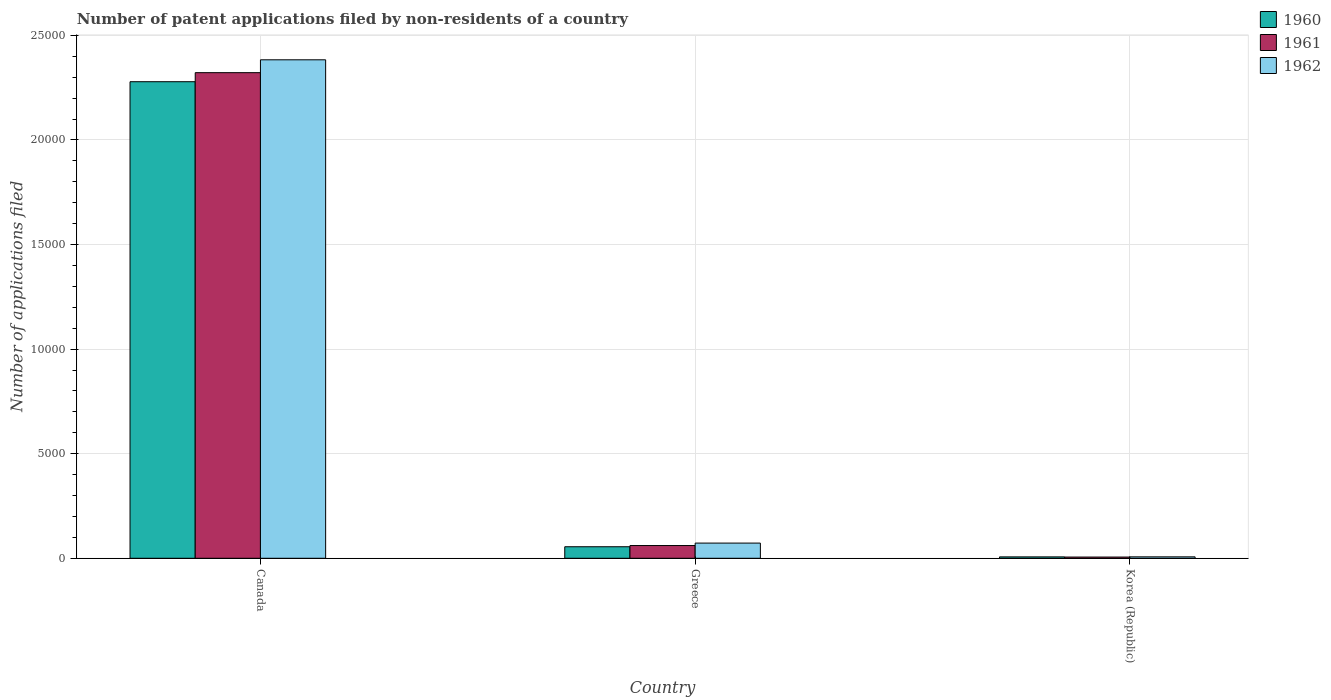How many different coloured bars are there?
Make the answer very short. 3. How many groups of bars are there?
Ensure brevity in your answer.  3. Are the number of bars per tick equal to the number of legend labels?
Provide a succinct answer. Yes. Are the number of bars on each tick of the X-axis equal?
Give a very brief answer. Yes. What is the number of applications filed in 1962 in Greece?
Offer a very short reply. 726. Across all countries, what is the maximum number of applications filed in 1961?
Offer a terse response. 2.32e+04. What is the total number of applications filed in 1962 in the graph?
Your response must be concise. 2.46e+04. What is the difference between the number of applications filed in 1960 in Canada and that in Greece?
Offer a terse response. 2.22e+04. What is the difference between the number of applications filed in 1962 in Greece and the number of applications filed in 1960 in Canada?
Your answer should be compact. -2.21e+04. What is the average number of applications filed in 1962 per country?
Provide a short and direct response. 8209.33. What is the difference between the number of applications filed of/in 1960 and number of applications filed of/in 1961 in Korea (Republic)?
Your answer should be very brief. 8. In how many countries, is the number of applications filed in 1962 greater than 17000?
Make the answer very short. 1. What is the ratio of the number of applications filed in 1960 in Canada to that in Greece?
Your response must be concise. 41.35. Is the number of applications filed in 1960 in Canada less than that in Korea (Republic)?
Provide a short and direct response. No. Is the difference between the number of applications filed in 1960 in Canada and Korea (Republic) greater than the difference between the number of applications filed in 1961 in Canada and Korea (Republic)?
Offer a terse response. No. What is the difference between the highest and the second highest number of applications filed in 1960?
Ensure brevity in your answer.  2.27e+04. What is the difference between the highest and the lowest number of applications filed in 1960?
Keep it short and to the point. 2.27e+04. Is the sum of the number of applications filed in 1961 in Canada and Greece greater than the maximum number of applications filed in 1962 across all countries?
Your answer should be compact. No. What does the 2nd bar from the right in Canada represents?
Your answer should be compact. 1961. Is it the case that in every country, the sum of the number of applications filed in 1962 and number of applications filed in 1960 is greater than the number of applications filed in 1961?
Your response must be concise. Yes. How many bars are there?
Offer a very short reply. 9. Are all the bars in the graph horizontal?
Offer a terse response. No. How many countries are there in the graph?
Your answer should be very brief. 3. How are the legend labels stacked?
Your answer should be very brief. Vertical. What is the title of the graph?
Offer a very short reply. Number of patent applications filed by non-residents of a country. What is the label or title of the X-axis?
Provide a succinct answer. Country. What is the label or title of the Y-axis?
Your response must be concise. Number of applications filed. What is the Number of applications filed in 1960 in Canada?
Your answer should be very brief. 2.28e+04. What is the Number of applications filed of 1961 in Canada?
Make the answer very short. 2.32e+04. What is the Number of applications filed in 1962 in Canada?
Provide a succinct answer. 2.38e+04. What is the Number of applications filed of 1960 in Greece?
Your answer should be compact. 551. What is the Number of applications filed of 1961 in Greece?
Ensure brevity in your answer.  609. What is the Number of applications filed of 1962 in Greece?
Your response must be concise. 726. What is the Number of applications filed of 1961 in Korea (Republic)?
Ensure brevity in your answer.  58. Across all countries, what is the maximum Number of applications filed of 1960?
Offer a terse response. 2.28e+04. Across all countries, what is the maximum Number of applications filed of 1961?
Offer a terse response. 2.32e+04. Across all countries, what is the maximum Number of applications filed of 1962?
Keep it short and to the point. 2.38e+04. Across all countries, what is the minimum Number of applications filed of 1960?
Ensure brevity in your answer.  66. Across all countries, what is the minimum Number of applications filed of 1962?
Provide a short and direct response. 68. What is the total Number of applications filed of 1960 in the graph?
Provide a succinct answer. 2.34e+04. What is the total Number of applications filed in 1961 in the graph?
Your response must be concise. 2.39e+04. What is the total Number of applications filed in 1962 in the graph?
Give a very brief answer. 2.46e+04. What is the difference between the Number of applications filed of 1960 in Canada and that in Greece?
Give a very brief answer. 2.22e+04. What is the difference between the Number of applications filed in 1961 in Canada and that in Greece?
Provide a succinct answer. 2.26e+04. What is the difference between the Number of applications filed of 1962 in Canada and that in Greece?
Keep it short and to the point. 2.31e+04. What is the difference between the Number of applications filed of 1960 in Canada and that in Korea (Republic)?
Offer a terse response. 2.27e+04. What is the difference between the Number of applications filed of 1961 in Canada and that in Korea (Republic)?
Keep it short and to the point. 2.32e+04. What is the difference between the Number of applications filed in 1962 in Canada and that in Korea (Republic)?
Offer a very short reply. 2.38e+04. What is the difference between the Number of applications filed in 1960 in Greece and that in Korea (Republic)?
Offer a terse response. 485. What is the difference between the Number of applications filed in 1961 in Greece and that in Korea (Republic)?
Your response must be concise. 551. What is the difference between the Number of applications filed in 1962 in Greece and that in Korea (Republic)?
Provide a short and direct response. 658. What is the difference between the Number of applications filed of 1960 in Canada and the Number of applications filed of 1961 in Greece?
Your response must be concise. 2.22e+04. What is the difference between the Number of applications filed in 1960 in Canada and the Number of applications filed in 1962 in Greece?
Keep it short and to the point. 2.21e+04. What is the difference between the Number of applications filed in 1961 in Canada and the Number of applications filed in 1962 in Greece?
Make the answer very short. 2.25e+04. What is the difference between the Number of applications filed of 1960 in Canada and the Number of applications filed of 1961 in Korea (Republic)?
Your answer should be compact. 2.27e+04. What is the difference between the Number of applications filed of 1960 in Canada and the Number of applications filed of 1962 in Korea (Republic)?
Ensure brevity in your answer.  2.27e+04. What is the difference between the Number of applications filed in 1961 in Canada and the Number of applications filed in 1962 in Korea (Republic)?
Provide a short and direct response. 2.32e+04. What is the difference between the Number of applications filed of 1960 in Greece and the Number of applications filed of 1961 in Korea (Republic)?
Offer a very short reply. 493. What is the difference between the Number of applications filed in 1960 in Greece and the Number of applications filed in 1962 in Korea (Republic)?
Ensure brevity in your answer.  483. What is the difference between the Number of applications filed in 1961 in Greece and the Number of applications filed in 1962 in Korea (Republic)?
Offer a terse response. 541. What is the average Number of applications filed of 1960 per country?
Provide a succinct answer. 7801. What is the average Number of applications filed of 1961 per country?
Your answer should be very brief. 7962. What is the average Number of applications filed in 1962 per country?
Keep it short and to the point. 8209.33. What is the difference between the Number of applications filed of 1960 and Number of applications filed of 1961 in Canada?
Your answer should be compact. -433. What is the difference between the Number of applications filed in 1960 and Number of applications filed in 1962 in Canada?
Give a very brief answer. -1048. What is the difference between the Number of applications filed of 1961 and Number of applications filed of 1962 in Canada?
Provide a short and direct response. -615. What is the difference between the Number of applications filed of 1960 and Number of applications filed of 1961 in Greece?
Keep it short and to the point. -58. What is the difference between the Number of applications filed in 1960 and Number of applications filed in 1962 in Greece?
Your answer should be very brief. -175. What is the difference between the Number of applications filed in 1961 and Number of applications filed in 1962 in Greece?
Give a very brief answer. -117. What is the difference between the Number of applications filed of 1960 and Number of applications filed of 1961 in Korea (Republic)?
Your answer should be very brief. 8. What is the difference between the Number of applications filed of 1960 and Number of applications filed of 1962 in Korea (Republic)?
Provide a short and direct response. -2. What is the difference between the Number of applications filed in 1961 and Number of applications filed in 1962 in Korea (Republic)?
Your answer should be compact. -10. What is the ratio of the Number of applications filed in 1960 in Canada to that in Greece?
Offer a terse response. 41.35. What is the ratio of the Number of applications filed of 1961 in Canada to that in Greece?
Offer a very short reply. 38.13. What is the ratio of the Number of applications filed in 1962 in Canada to that in Greece?
Make the answer very short. 32.83. What is the ratio of the Number of applications filed of 1960 in Canada to that in Korea (Republic)?
Provide a short and direct response. 345.24. What is the ratio of the Number of applications filed of 1961 in Canada to that in Korea (Republic)?
Provide a succinct answer. 400.33. What is the ratio of the Number of applications filed of 1962 in Canada to that in Korea (Republic)?
Provide a short and direct response. 350.5. What is the ratio of the Number of applications filed in 1960 in Greece to that in Korea (Republic)?
Keep it short and to the point. 8.35. What is the ratio of the Number of applications filed of 1962 in Greece to that in Korea (Republic)?
Keep it short and to the point. 10.68. What is the difference between the highest and the second highest Number of applications filed in 1960?
Your answer should be compact. 2.22e+04. What is the difference between the highest and the second highest Number of applications filed in 1961?
Give a very brief answer. 2.26e+04. What is the difference between the highest and the second highest Number of applications filed of 1962?
Offer a very short reply. 2.31e+04. What is the difference between the highest and the lowest Number of applications filed in 1960?
Make the answer very short. 2.27e+04. What is the difference between the highest and the lowest Number of applications filed of 1961?
Keep it short and to the point. 2.32e+04. What is the difference between the highest and the lowest Number of applications filed of 1962?
Your response must be concise. 2.38e+04. 